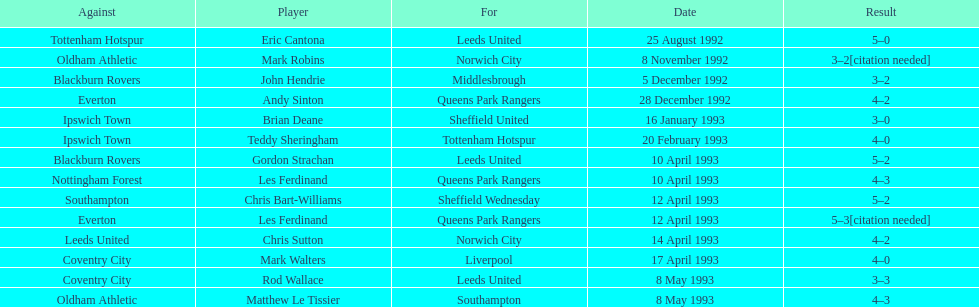Name the players for tottenham hotspur. Teddy Sheringham. 